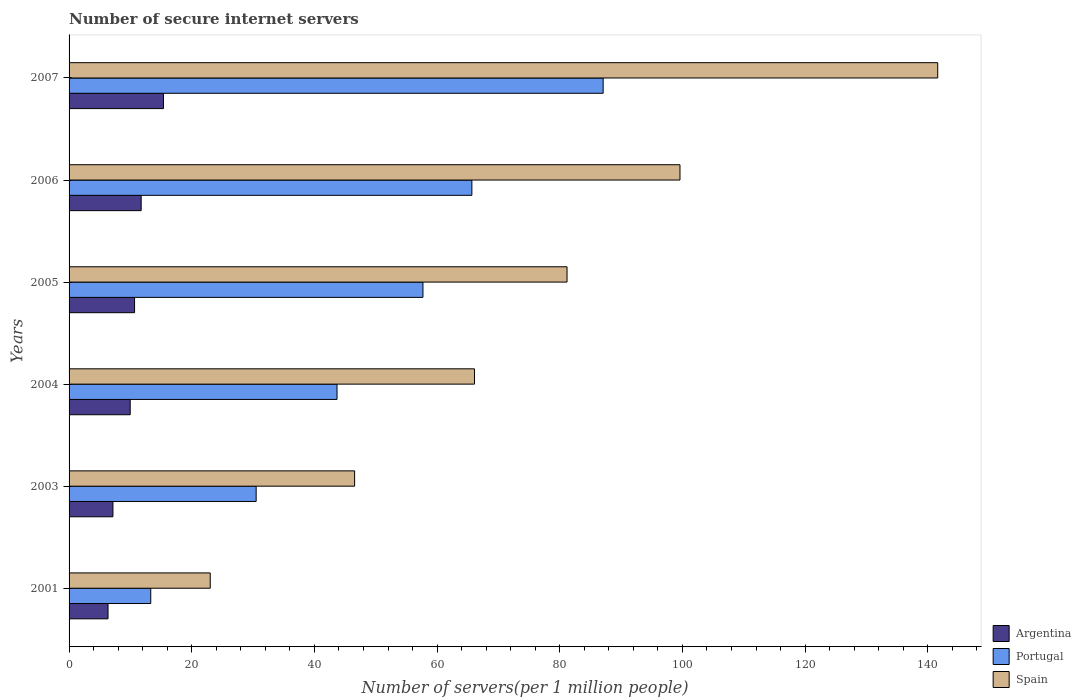How many different coloured bars are there?
Your response must be concise. 3. How many bars are there on the 4th tick from the top?
Make the answer very short. 3. In how many cases, is the number of bars for a given year not equal to the number of legend labels?
Provide a short and direct response. 0. What is the number of secure internet servers in Argentina in 2006?
Offer a terse response. 11.75. Across all years, what is the maximum number of secure internet servers in Argentina?
Your response must be concise. 15.39. Across all years, what is the minimum number of secure internet servers in Argentina?
Provide a succinct answer. 6.35. What is the total number of secure internet servers in Argentina in the graph?
Provide a short and direct response. 61.29. What is the difference between the number of secure internet servers in Spain in 2003 and that in 2006?
Offer a very short reply. -53.05. What is the difference between the number of secure internet servers in Portugal in 2004 and the number of secure internet servers in Spain in 2005?
Provide a succinct answer. -37.5. What is the average number of secure internet servers in Argentina per year?
Your response must be concise. 10.21. In the year 2005, what is the difference between the number of secure internet servers in Argentina and number of secure internet servers in Portugal?
Give a very brief answer. -47.02. What is the ratio of the number of secure internet servers in Portugal in 2003 to that in 2007?
Offer a terse response. 0.35. Is the number of secure internet servers in Argentina in 2006 less than that in 2007?
Offer a terse response. Yes. What is the difference between the highest and the second highest number of secure internet servers in Portugal?
Offer a very short reply. 21.4. What is the difference between the highest and the lowest number of secure internet servers in Argentina?
Your answer should be compact. 9.04. In how many years, is the number of secure internet servers in Argentina greater than the average number of secure internet servers in Argentina taken over all years?
Provide a succinct answer. 3. What does the 2nd bar from the top in 2001 represents?
Ensure brevity in your answer.  Portugal. How many bars are there?
Provide a short and direct response. 18. Are all the bars in the graph horizontal?
Offer a very short reply. Yes. How many years are there in the graph?
Ensure brevity in your answer.  6. Are the values on the major ticks of X-axis written in scientific E-notation?
Provide a short and direct response. No. Does the graph contain any zero values?
Your answer should be compact. No. Where does the legend appear in the graph?
Keep it short and to the point. Bottom right. How many legend labels are there?
Provide a succinct answer. 3. What is the title of the graph?
Provide a short and direct response. Number of secure internet servers. What is the label or title of the X-axis?
Keep it short and to the point. Number of servers(per 1 million people). What is the label or title of the Y-axis?
Your answer should be compact. Years. What is the Number of servers(per 1 million people) of Argentina in 2001?
Give a very brief answer. 6.35. What is the Number of servers(per 1 million people) in Portugal in 2001?
Provide a short and direct response. 13.32. What is the Number of servers(per 1 million people) in Spain in 2001?
Provide a short and direct response. 23.02. What is the Number of servers(per 1 million people) of Argentina in 2003?
Your answer should be compact. 7.15. What is the Number of servers(per 1 million people) in Portugal in 2003?
Provide a succinct answer. 30.5. What is the Number of servers(per 1 million people) in Spain in 2003?
Ensure brevity in your answer.  46.55. What is the Number of servers(per 1 million people) of Argentina in 2004?
Provide a short and direct response. 9.97. What is the Number of servers(per 1 million people) of Portugal in 2004?
Make the answer very short. 43.69. What is the Number of servers(per 1 million people) of Spain in 2004?
Make the answer very short. 66.1. What is the Number of servers(per 1 million people) of Argentina in 2005?
Give a very brief answer. 10.68. What is the Number of servers(per 1 million people) of Portugal in 2005?
Ensure brevity in your answer.  57.7. What is the Number of servers(per 1 million people) in Spain in 2005?
Give a very brief answer. 81.19. What is the Number of servers(per 1 million people) of Argentina in 2006?
Your answer should be very brief. 11.75. What is the Number of servers(per 1 million people) in Portugal in 2006?
Your answer should be compact. 65.67. What is the Number of servers(per 1 million people) in Spain in 2006?
Your answer should be very brief. 99.6. What is the Number of servers(per 1 million people) in Argentina in 2007?
Ensure brevity in your answer.  15.39. What is the Number of servers(per 1 million people) of Portugal in 2007?
Provide a succinct answer. 87.07. What is the Number of servers(per 1 million people) of Spain in 2007?
Ensure brevity in your answer.  141.62. Across all years, what is the maximum Number of servers(per 1 million people) in Argentina?
Offer a terse response. 15.39. Across all years, what is the maximum Number of servers(per 1 million people) of Portugal?
Offer a terse response. 87.07. Across all years, what is the maximum Number of servers(per 1 million people) of Spain?
Make the answer very short. 141.62. Across all years, what is the minimum Number of servers(per 1 million people) in Argentina?
Give a very brief answer. 6.35. Across all years, what is the minimum Number of servers(per 1 million people) in Portugal?
Your response must be concise. 13.32. Across all years, what is the minimum Number of servers(per 1 million people) of Spain?
Your answer should be very brief. 23.02. What is the total Number of servers(per 1 million people) in Argentina in the graph?
Your response must be concise. 61.29. What is the total Number of servers(per 1 million people) of Portugal in the graph?
Provide a short and direct response. 297.94. What is the total Number of servers(per 1 million people) in Spain in the graph?
Ensure brevity in your answer.  458.07. What is the difference between the Number of servers(per 1 million people) in Argentina in 2001 and that in 2003?
Your answer should be very brief. -0.8. What is the difference between the Number of servers(per 1 million people) of Portugal in 2001 and that in 2003?
Give a very brief answer. -17.18. What is the difference between the Number of servers(per 1 million people) in Spain in 2001 and that in 2003?
Offer a terse response. -23.54. What is the difference between the Number of servers(per 1 million people) of Argentina in 2001 and that in 2004?
Provide a short and direct response. -3.62. What is the difference between the Number of servers(per 1 million people) in Portugal in 2001 and that in 2004?
Your answer should be very brief. -30.37. What is the difference between the Number of servers(per 1 million people) of Spain in 2001 and that in 2004?
Offer a terse response. -43.08. What is the difference between the Number of servers(per 1 million people) of Argentina in 2001 and that in 2005?
Give a very brief answer. -4.33. What is the difference between the Number of servers(per 1 million people) of Portugal in 2001 and that in 2005?
Your response must be concise. -44.38. What is the difference between the Number of servers(per 1 million people) in Spain in 2001 and that in 2005?
Provide a succinct answer. -58.17. What is the difference between the Number of servers(per 1 million people) of Argentina in 2001 and that in 2006?
Keep it short and to the point. -5.4. What is the difference between the Number of servers(per 1 million people) of Portugal in 2001 and that in 2006?
Your answer should be compact. -52.35. What is the difference between the Number of servers(per 1 million people) of Spain in 2001 and that in 2006?
Your answer should be very brief. -76.59. What is the difference between the Number of servers(per 1 million people) in Argentina in 2001 and that in 2007?
Offer a terse response. -9.04. What is the difference between the Number of servers(per 1 million people) in Portugal in 2001 and that in 2007?
Offer a terse response. -73.76. What is the difference between the Number of servers(per 1 million people) of Spain in 2001 and that in 2007?
Your response must be concise. -118.6. What is the difference between the Number of servers(per 1 million people) in Argentina in 2003 and that in 2004?
Ensure brevity in your answer.  -2.81. What is the difference between the Number of servers(per 1 million people) of Portugal in 2003 and that in 2004?
Offer a terse response. -13.19. What is the difference between the Number of servers(per 1 million people) in Spain in 2003 and that in 2004?
Offer a terse response. -19.54. What is the difference between the Number of servers(per 1 million people) of Argentina in 2003 and that in 2005?
Offer a terse response. -3.53. What is the difference between the Number of servers(per 1 million people) in Portugal in 2003 and that in 2005?
Your answer should be compact. -27.2. What is the difference between the Number of servers(per 1 million people) of Spain in 2003 and that in 2005?
Keep it short and to the point. -34.63. What is the difference between the Number of servers(per 1 million people) of Argentina in 2003 and that in 2006?
Keep it short and to the point. -4.6. What is the difference between the Number of servers(per 1 million people) in Portugal in 2003 and that in 2006?
Give a very brief answer. -35.17. What is the difference between the Number of servers(per 1 million people) in Spain in 2003 and that in 2006?
Provide a short and direct response. -53.05. What is the difference between the Number of servers(per 1 million people) in Argentina in 2003 and that in 2007?
Give a very brief answer. -8.23. What is the difference between the Number of servers(per 1 million people) of Portugal in 2003 and that in 2007?
Make the answer very short. -56.57. What is the difference between the Number of servers(per 1 million people) in Spain in 2003 and that in 2007?
Make the answer very short. -95.07. What is the difference between the Number of servers(per 1 million people) in Argentina in 2004 and that in 2005?
Your response must be concise. -0.71. What is the difference between the Number of servers(per 1 million people) of Portugal in 2004 and that in 2005?
Provide a short and direct response. -14.01. What is the difference between the Number of servers(per 1 million people) of Spain in 2004 and that in 2005?
Give a very brief answer. -15.09. What is the difference between the Number of servers(per 1 million people) of Argentina in 2004 and that in 2006?
Your answer should be very brief. -1.79. What is the difference between the Number of servers(per 1 million people) in Portugal in 2004 and that in 2006?
Your answer should be very brief. -21.98. What is the difference between the Number of servers(per 1 million people) of Spain in 2004 and that in 2006?
Keep it short and to the point. -33.5. What is the difference between the Number of servers(per 1 million people) of Argentina in 2004 and that in 2007?
Keep it short and to the point. -5.42. What is the difference between the Number of servers(per 1 million people) in Portugal in 2004 and that in 2007?
Your answer should be compact. -43.39. What is the difference between the Number of servers(per 1 million people) in Spain in 2004 and that in 2007?
Ensure brevity in your answer.  -75.52. What is the difference between the Number of servers(per 1 million people) of Argentina in 2005 and that in 2006?
Provide a succinct answer. -1.08. What is the difference between the Number of servers(per 1 million people) of Portugal in 2005 and that in 2006?
Your answer should be very brief. -7.97. What is the difference between the Number of servers(per 1 million people) of Spain in 2005 and that in 2006?
Provide a short and direct response. -18.42. What is the difference between the Number of servers(per 1 million people) of Argentina in 2005 and that in 2007?
Keep it short and to the point. -4.71. What is the difference between the Number of servers(per 1 million people) in Portugal in 2005 and that in 2007?
Give a very brief answer. -29.38. What is the difference between the Number of servers(per 1 million people) of Spain in 2005 and that in 2007?
Make the answer very short. -60.43. What is the difference between the Number of servers(per 1 million people) in Argentina in 2006 and that in 2007?
Offer a very short reply. -3.63. What is the difference between the Number of servers(per 1 million people) in Portugal in 2006 and that in 2007?
Ensure brevity in your answer.  -21.4. What is the difference between the Number of servers(per 1 million people) in Spain in 2006 and that in 2007?
Give a very brief answer. -42.02. What is the difference between the Number of servers(per 1 million people) in Argentina in 2001 and the Number of servers(per 1 million people) in Portugal in 2003?
Your answer should be very brief. -24.15. What is the difference between the Number of servers(per 1 million people) of Argentina in 2001 and the Number of servers(per 1 million people) of Spain in 2003?
Offer a very short reply. -40.2. What is the difference between the Number of servers(per 1 million people) in Portugal in 2001 and the Number of servers(per 1 million people) in Spain in 2003?
Your answer should be very brief. -33.24. What is the difference between the Number of servers(per 1 million people) of Argentina in 2001 and the Number of servers(per 1 million people) of Portugal in 2004?
Offer a terse response. -37.33. What is the difference between the Number of servers(per 1 million people) of Argentina in 2001 and the Number of servers(per 1 million people) of Spain in 2004?
Make the answer very short. -59.75. What is the difference between the Number of servers(per 1 million people) of Portugal in 2001 and the Number of servers(per 1 million people) of Spain in 2004?
Give a very brief answer. -52.78. What is the difference between the Number of servers(per 1 million people) in Argentina in 2001 and the Number of servers(per 1 million people) in Portugal in 2005?
Keep it short and to the point. -51.34. What is the difference between the Number of servers(per 1 million people) in Argentina in 2001 and the Number of servers(per 1 million people) in Spain in 2005?
Offer a very short reply. -74.83. What is the difference between the Number of servers(per 1 million people) of Portugal in 2001 and the Number of servers(per 1 million people) of Spain in 2005?
Offer a terse response. -67.87. What is the difference between the Number of servers(per 1 million people) of Argentina in 2001 and the Number of servers(per 1 million people) of Portugal in 2006?
Ensure brevity in your answer.  -59.32. What is the difference between the Number of servers(per 1 million people) in Argentina in 2001 and the Number of servers(per 1 million people) in Spain in 2006?
Your answer should be very brief. -93.25. What is the difference between the Number of servers(per 1 million people) in Portugal in 2001 and the Number of servers(per 1 million people) in Spain in 2006?
Provide a short and direct response. -86.28. What is the difference between the Number of servers(per 1 million people) in Argentina in 2001 and the Number of servers(per 1 million people) in Portugal in 2007?
Your answer should be compact. -80.72. What is the difference between the Number of servers(per 1 million people) of Argentina in 2001 and the Number of servers(per 1 million people) of Spain in 2007?
Your answer should be compact. -135.27. What is the difference between the Number of servers(per 1 million people) in Portugal in 2001 and the Number of servers(per 1 million people) in Spain in 2007?
Keep it short and to the point. -128.3. What is the difference between the Number of servers(per 1 million people) in Argentina in 2003 and the Number of servers(per 1 million people) in Portugal in 2004?
Your answer should be very brief. -36.53. What is the difference between the Number of servers(per 1 million people) in Argentina in 2003 and the Number of servers(per 1 million people) in Spain in 2004?
Your response must be concise. -58.94. What is the difference between the Number of servers(per 1 million people) of Portugal in 2003 and the Number of servers(per 1 million people) of Spain in 2004?
Your answer should be very brief. -35.6. What is the difference between the Number of servers(per 1 million people) in Argentina in 2003 and the Number of servers(per 1 million people) in Portugal in 2005?
Your answer should be compact. -50.54. What is the difference between the Number of servers(per 1 million people) of Argentina in 2003 and the Number of servers(per 1 million people) of Spain in 2005?
Provide a short and direct response. -74.03. What is the difference between the Number of servers(per 1 million people) in Portugal in 2003 and the Number of servers(per 1 million people) in Spain in 2005?
Offer a very short reply. -50.68. What is the difference between the Number of servers(per 1 million people) of Argentina in 2003 and the Number of servers(per 1 million people) of Portugal in 2006?
Your answer should be very brief. -58.52. What is the difference between the Number of servers(per 1 million people) in Argentina in 2003 and the Number of servers(per 1 million people) in Spain in 2006?
Offer a terse response. -92.45. What is the difference between the Number of servers(per 1 million people) of Portugal in 2003 and the Number of servers(per 1 million people) of Spain in 2006?
Offer a terse response. -69.1. What is the difference between the Number of servers(per 1 million people) in Argentina in 2003 and the Number of servers(per 1 million people) in Portugal in 2007?
Provide a succinct answer. -79.92. What is the difference between the Number of servers(per 1 million people) in Argentina in 2003 and the Number of servers(per 1 million people) in Spain in 2007?
Your answer should be compact. -134.47. What is the difference between the Number of servers(per 1 million people) in Portugal in 2003 and the Number of servers(per 1 million people) in Spain in 2007?
Keep it short and to the point. -111.12. What is the difference between the Number of servers(per 1 million people) in Argentina in 2004 and the Number of servers(per 1 million people) in Portugal in 2005?
Ensure brevity in your answer.  -47.73. What is the difference between the Number of servers(per 1 million people) in Argentina in 2004 and the Number of servers(per 1 million people) in Spain in 2005?
Offer a terse response. -71.22. What is the difference between the Number of servers(per 1 million people) in Portugal in 2004 and the Number of servers(per 1 million people) in Spain in 2005?
Your answer should be compact. -37.5. What is the difference between the Number of servers(per 1 million people) in Argentina in 2004 and the Number of servers(per 1 million people) in Portugal in 2006?
Keep it short and to the point. -55.7. What is the difference between the Number of servers(per 1 million people) in Argentina in 2004 and the Number of servers(per 1 million people) in Spain in 2006?
Ensure brevity in your answer.  -89.63. What is the difference between the Number of servers(per 1 million people) in Portugal in 2004 and the Number of servers(per 1 million people) in Spain in 2006?
Your answer should be compact. -55.91. What is the difference between the Number of servers(per 1 million people) in Argentina in 2004 and the Number of servers(per 1 million people) in Portugal in 2007?
Your answer should be very brief. -77.11. What is the difference between the Number of servers(per 1 million people) of Argentina in 2004 and the Number of servers(per 1 million people) of Spain in 2007?
Provide a short and direct response. -131.65. What is the difference between the Number of servers(per 1 million people) of Portugal in 2004 and the Number of servers(per 1 million people) of Spain in 2007?
Your response must be concise. -97.93. What is the difference between the Number of servers(per 1 million people) in Argentina in 2005 and the Number of servers(per 1 million people) in Portugal in 2006?
Your response must be concise. -54.99. What is the difference between the Number of servers(per 1 million people) of Argentina in 2005 and the Number of servers(per 1 million people) of Spain in 2006?
Keep it short and to the point. -88.92. What is the difference between the Number of servers(per 1 million people) of Portugal in 2005 and the Number of servers(per 1 million people) of Spain in 2006?
Offer a very short reply. -41.9. What is the difference between the Number of servers(per 1 million people) of Argentina in 2005 and the Number of servers(per 1 million people) of Portugal in 2007?
Offer a very short reply. -76.39. What is the difference between the Number of servers(per 1 million people) in Argentina in 2005 and the Number of servers(per 1 million people) in Spain in 2007?
Provide a succinct answer. -130.94. What is the difference between the Number of servers(per 1 million people) of Portugal in 2005 and the Number of servers(per 1 million people) of Spain in 2007?
Your answer should be very brief. -83.92. What is the difference between the Number of servers(per 1 million people) of Argentina in 2006 and the Number of servers(per 1 million people) of Portugal in 2007?
Ensure brevity in your answer.  -75.32. What is the difference between the Number of servers(per 1 million people) of Argentina in 2006 and the Number of servers(per 1 million people) of Spain in 2007?
Your response must be concise. -129.86. What is the difference between the Number of servers(per 1 million people) in Portugal in 2006 and the Number of servers(per 1 million people) in Spain in 2007?
Your answer should be compact. -75.95. What is the average Number of servers(per 1 million people) of Argentina per year?
Offer a very short reply. 10.21. What is the average Number of servers(per 1 million people) of Portugal per year?
Keep it short and to the point. 49.66. What is the average Number of servers(per 1 million people) of Spain per year?
Make the answer very short. 76.35. In the year 2001, what is the difference between the Number of servers(per 1 million people) of Argentina and Number of servers(per 1 million people) of Portugal?
Offer a terse response. -6.97. In the year 2001, what is the difference between the Number of servers(per 1 million people) of Argentina and Number of servers(per 1 million people) of Spain?
Your answer should be compact. -16.66. In the year 2001, what is the difference between the Number of servers(per 1 million people) of Portugal and Number of servers(per 1 million people) of Spain?
Provide a short and direct response. -9.7. In the year 2003, what is the difference between the Number of servers(per 1 million people) of Argentina and Number of servers(per 1 million people) of Portugal?
Keep it short and to the point. -23.35. In the year 2003, what is the difference between the Number of servers(per 1 million people) of Argentina and Number of servers(per 1 million people) of Spain?
Offer a terse response. -39.4. In the year 2003, what is the difference between the Number of servers(per 1 million people) of Portugal and Number of servers(per 1 million people) of Spain?
Give a very brief answer. -16.05. In the year 2004, what is the difference between the Number of servers(per 1 million people) of Argentina and Number of servers(per 1 million people) of Portugal?
Your answer should be compact. -33.72. In the year 2004, what is the difference between the Number of servers(per 1 million people) in Argentina and Number of servers(per 1 million people) in Spain?
Provide a succinct answer. -56.13. In the year 2004, what is the difference between the Number of servers(per 1 million people) in Portugal and Number of servers(per 1 million people) in Spain?
Provide a succinct answer. -22.41. In the year 2005, what is the difference between the Number of servers(per 1 million people) in Argentina and Number of servers(per 1 million people) in Portugal?
Ensure brevity in your answer.  -47.02. In the year 2005, what is the difference between the Number of servers(per 1 million people) in Argentina and Number of servers(per 1 million people) in Spain?
Your answer should be very brief. -70.51. In the year 2005, what is the difference between the Number of servers(per 1 million people) in Portugal and Number of servers(per 1 million people) in Spain?
Provide a short and direct response. -23.49. In the year 2006, what is the difference between the Number of servers(per 1 million people) in Argentina and Number of servers(per 1 million people) in Portugal?
Make the answer very short. -53.92. In the year 2006, what is the difference between the Number of servers(per 1 million people) of Argentina and Number of servers(per 1 million people) of Spain?
Offer a terse response. -87.85. In the year 2006, what is the difference between the Number of servers(per 1 million people) in Portugal and Number of servers(per 1 million people) in Spain?
Your response must be concise. -33.93. In the year 2007, what is the difference between the Number of servers(per 1 million people) in Argentina and Number of servers(per 1 million people) in Portugal?
Your answer should be compact. -71.69. In the year 2007, what is the difference between the Number of servers(per 1 million people) of Argentina and Number of servers(per 1 million people) of Spain?
Your answer should be compact. -126.23. In the year 2007, what is the difference between the Number of servers(per 1 million people) in Portugal and Number of servers(per 1 million people) in Spain?
Ensure brevity in your answer.  -54.55. What is the ratio of the Number of servers(per 1 million people) of Argentina in 2001 to that in 2003?
Give a very brief answer. 0.89. What is the ratio of the Number of servers(per 1 million people) in Portugal in 2001 to that in 2003?
Offer a very short reply. 0.44. What is the ratio of the Number of servers(per 1 million people) in Spain in 2001 to that in 2003?
Your answer should be very brief. 0.49. What is the ratio of the Number of servers(per 1 million people) of Argentina in 2001 to that in 2004?
Offer a very short reply. 0.64. What is the ratio of the Number of servers(per 1 million people) of Portugal in 2001 to that in 2004?
Provide a short and direct response. 0.3. What is the ratio of the Number of servers(per 1 million people) in Spain in 2001 to that in 2004?
Offer a very short reply. 0.35. What is the ratio of the Number of servers(per 1 million people) of Argentina in 2001 to that in 2005?
Your answer should be compact. 0.59. What is the ratio of the Number of servers(per 1 million people) of Portugal in 2001 to that in 2005?
Make the answer very short. 0.23. What is the ratio of the Number of servers(per 1 million people) of Spain in 2001 to that in 2005?
Make the answer very short. 0.28. What is the ratio of the Number of servers(per 1 million people) of Argentina in 2001 to that in 2006?
Your answer should be very brief. 0.54. What is the ratio of the Number of servers(per 1 million people) in Portugal in 2001 to that in 2006?
Keep it short and to the point. 0.2. What is the ratio of the Number of servers(per 1 million people) in Spain in 2001 to that in 2006?
Your answer should be compact. 0.23. What is the ratio of the Number of servers(per 1 million people) in Argentina in 2001 to that in 2007?
Your answer should be compact. 0.41. What is the ratio of the Number of servers(per 1 million people) in Portugal in 2001 to that in 2007?
Provide a short and direct response. 0.15. What is the ratio of the Number of servers(per 1 million people) of Spain in 2001 to that in 2007?
Provide a succinct answer. 0.16. What is the ratio of the Number of servers(per 1 million people) of Argentina in 2003 to that in 2004?
Make the answer very short. 0.72. What is the ratio of the Number of servers(per 1 million people) of Portugal in 2003 to that in 2004?
Give a very brief answer. 0.7. What is the ratio of the Number of servers(per 1 million people) of Spain in 2003 to that in 2004?
Offer a terse response. 0.7. What is the ratio of the Number of servers(per 1 million people) in Argentina in 2003 to that in 2005?
Give a very brief answer. 0.67. What is the ratio of the Number of servers(per 1 million people) of Portugal in 2003 to that in 2005?
Offer a very short reply. 0.53. What is the ratio of the Number of servers(per 1 million people) of Spain in 2003 to that in 2005?
Ensure brevity in your answer.  0.57. What is the ratio of the Number of servers(per 1 million people) of Argentina in 2003 to that in 2006?
Make the answer very short. 0.61. What is the ratio of the Number of servers(per 1 million people) of Portugal in 2003 to that in 2006?
Provide a short and direct response. 0.46. What is the ratio of the Number of servers(per 1 million people) of Spain in 2003 to that in 2006?
Your response must be concise. 0.47. What is the ratio of the Number of servers(per 1 million people) of Argentina in 2003 to that in 2007?
Provide a short and direct response. 0.46. What is the ratio of the Number of servers(per 1 million people) of Portugal in 2003 to that in 2007?
Give a very brief answer. 0.35. What is the ratio of the Number of servers(per 1 million people) of Spain in 2003 to that in 2007?
Your response must be concise. 0.33. What is the ratio of the Number of servers(per 1 million people) of Argentina in 2004 to that in 2005?
Your answer should be very brief. 0.93. What is the ratio of the Number of servers(per 1 million people) of Portugal in 2004 to that in 2005?
Ensure brevity in your answer.  0.76. What is the ratio of the Number of servers(per 1 million people) of Spain in 2004 to that in 2005?
Provide a short and direct response. 0.81. What is the ratio of the Number of servers(per 1 million people) in Argentina in 2004 to that in 2006?
Your response must be concise. 0.85. What is the ratio of the Number of servers(per 1 million people) in Portugal in 2004 to that in 2006?
Make the answer very short. 0.67. What is the ratio of the Number of servers(per 1 million people) of Spain in 2004 to that in 2006?
Your answer should be compact. 0.66. What is the ratio of the Number of servers(per 1 million people) of Argentina in 2004 to that in 2007?
Your response must be concise. 0.65. What is the ratio of the Number of servers(per 1 million people) in Portugal in 2004 to that in 2007?
Your answer should be compact. 0.5. What is the ratio of the Number of servers(per 1 million people) in Spain in 2004 to that in 2007?
Your answer should be very brief. 0.47. What is the ratio of the Number of servers(per 1 million people) of Argentina in 2005 to that in 2006?
Your response must be concise. 0.91. What is the ratio of the Number of servers(per 1 million people) in Portugal in 2005 to that in 2006?
Keep it short and to the point. 0.88. What is the ratio of the Number of servers(per 1 million people) in Spain in 2005 to that in 2006?
Ensure brevity in your answer.  0.82. What is the ratio of the Number of servers(per 1 million people) of Argentina in 2005 to that in 2007?
Ensure brevity in your answer.  0.69. What is the ratio of the Number of servers(per 1 million people) of Portugal in 2005 to that in 2007?
Ensure brevity in your answer.  0.66. What is the ratio of the Number of servers(per 1 million people) in Spain in 2005 to that in 2007?
Give a very brief answer. 0.57. What is the ratio of the Number of servers(per 1 million people) in Argentina in 2006 to that in 2007?
Your response must be concise. 0.76. What is the ratio of the Number of servers(per 1 million people) in Portugal in 2006 to that in 2007?
Ensure brevity in your answer.  0.75. What is the ratio of the Number of servers(per 1 million people) of Spain in 2006 to that in 2007?
Your answer should be compact. 0.7. What is the difference between the highest and the second highest Number of servers(per 1 million people) of Argentina?
Your answer should be compact. 3.63. What is the difference between the highest and the second highest Number of servers(per 1 million people) of Portugal?
Provide a short and direct response. 21.4. What is the difference between the highest and the second highest Number of servers(per 1 million people) of Spain?
Your response must be concise. 42.02. What is the difference between the highest and the lowest Number of servers(per 1 million people) in Argentina?
Your answer should be very brief. 9.04. What is the difference between the highest and the lowest Number of servers(per 1 million people) of Portugal?
Your answer should be very brief. 73.76. What is the difference between the highest and the lowest Number of servers(per 1 million people) in Spain?
Offer a terse response. 118.6. 